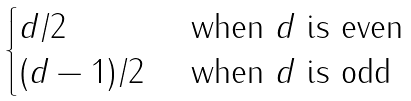Convert formula to latex. <formula><loc_0><loc_0><loc_500><loc_500>\begin{cases} d / 2 & \text { when $d$ is even } \\ ( d - 1 ) / 2 & \text { when $d$ is odd } \end{cases}</formula> 